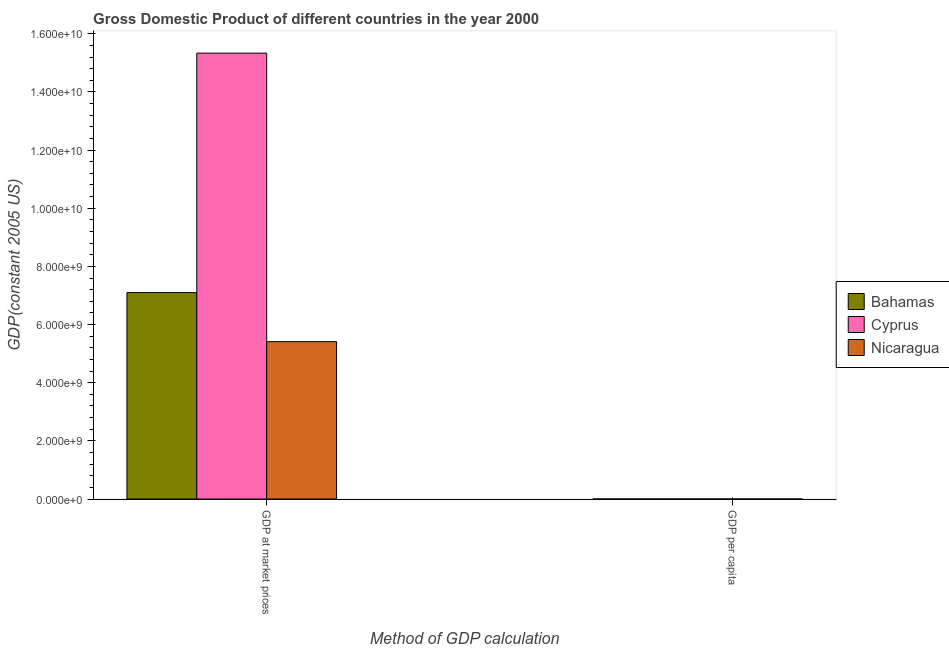How many different coloured bars are there?
Provide a succinct answer. 3. How many groups of bars are there?
Ensure brevity in your answer.  2. Are the number of bars on each tick of the X-axis equal?
Provide a short and direct response. Yes. How many bars are there on the 1st tick from the right?
Give a very brief answer. 3. What is the label of the 2nd group of bars from the left?
Provide a short and direct response. GDP per capita. What is the gdp at market prices in Bahamas?
Provide a short and direct response. 7.10e+09. Across all countries, what is the maximum gdp per capita?
Ensure brevity in your answer.  2.38e+04. Across all countries, what is the minimum gdp per capita?
Offer a terse response. 1076.67. In which country was the gdp per capita maximum?
Ensure brevity in your answer.  Bahamas. In which country was the gdp at market prices minimum?
Your answer should be compact. Nicaragua. What is the total gdp at market prices in the graph?
Provide a succinct answer. 2.78e+1. What is the difference between the gdp per capita in Nicaragua and that in Bahamas?
Provide a succinct answer. -2.28e+04. What is the difference between the gdp at market prices in Bahamas and the gdp per capita in Cyprus?
Your response must be concise. 7.10e+09. What is the average gdp per capita per country?
Ensure brevity in your answer.  1.57e+04. What is the difference between the gdp per capita and gdp at market prices in Nicaragua?
Make the answer very short. -5.41e+09. In how many countries, is the gdp at market prices greater than 10400000000 US$?
Keep it short and to the point. 1. What is the ratio of the gdp at market prices in Nicaragua to that in Cyprus?
Provide a succinct answer. 0.35. What does the 2nd bar from the left in GDP at market prices represents?
Your answer should be compact. Cyprus. What does the 3rd bar from the right in GDP per capita represents?
Give a very brief answer. Bahamas. How many bars are there?
Keep it short and to the point. 6. What is the difference between two consecutive major ticks on the Y-axis?
Ensure brevity in your answer.  2.00e+09. Does the graph contain any zero values?
Your answer should be very brief. No. Does the graph contain grids?
Ensure brevity in your answer.  No. How many legend labels are there?
Ensure brevity in your answer.  3. How are the legend labels stacked?
Offer a terse response. Vertical. What is the title of the graph?
Keep it short and to the point. Gross Domestic Product of different countries in the year 2000. Does "Fragile and conflict affected situations" appear as one of the legend labels in the graph?
Ensure brevity in your answer.  No. What is the label or title of the X-axis?
Offer a terse response. Method of GDP calculation. What is the label or title of the Y-axis?
Keep it short and to the point. GDP(constant 2005 US). What is the GDP(constant 2005 US) in Bahamas in GDP at market prices?
Provide a succinct answer. 7.10e+09. What is the GDP(constant 2005 US) in Cyprus in GDP at market prices?
Offer a terse response. 1.53e+1. What is the GDP(constant 2005 US) of Nicaragua in GDP at market prices?
Offer a very short reply. 5.41e+09. What is the GDP(constant 2005 US) of Bahamas in GDP per capita?
Your answer should be very brief. 2.38e+04. What is the GDP(constant 2005 US) in Cyprus in GDP per capita?
Your answer should be compact. 2.21e+04. What is the GDP(constant 2005 US) of Nicaragua in GDP per capita?
Your answer should be compact. 1076.67. Across all Method of GDP calculation, what is the maximum GDP(constant 2005 US) in Bahamas?
Your answer should be compact. 7.10e+09. Across all Method of GDP calculation, what is the maximum GDP(constant 2005 US) in Cyprus?
Offer a very short reply. 1.53e+1. Across all Method of GDP calculation, what is the maximum GDP(constant 2005 US) in Nicaragua?
Provide a succinct answer. 5.41e+09. Across all Method of GDP calculation, what is the minimum GDP(constant 2005 US) of Bahamas?
Your answer should be very brief. 2.38e+04. Across all Method of GDP calculation, what is the minimum GDP(constant 2005 US) in Cyprus?
Give a very brief answer. 2.21e+04. Across all Method of GDP calculation, what is the minimum GDP(constant 2005 US) of Nicaragua?
Your answer should be compact. 1076.67. What is the total GDP(constant 2005 US) of Bahamas in the graph?
Your answer should be compact. 7.10e+09. What is the total GDP(constant 2005 US) in Cyprus in the graph?
Make the answer very short. 1.53e+1. What is the total GDP(constant 2005 US) in Nicaragua in the graph?
Keep it short and to the point. 5.41e+09. What is the difference between the GDP(constant 2005 US) of Bahamas in GDP at market prices and that in GDP per capita?
Ensure brevity in your answer.  7.10e+09. What is the difference between the GDP(constant 2005 US) in Cyprus in GDP at market prices and that in GDP per capita?
Make the answer very short. 1.53e+1. What is the difference between the GDP(constant 2005 US) in Nicaragua in GDP at market prices and that in GDP per capita?
Your answer should be very brief. 5.41e+09. What is the difference between the GDP(constant 2005 US) in Bahamas in GDP at market prices and the GDP(constant 2005 US) in Cyprus in GDP per capita?
Provide a succinct answer. 7.10e+09. What is the difference between the GDP(constant 2005 US) of Bahamas in GDP at market prices and the GDP(constant 2005 US) of Nicaragua in GDP per capita?
Ensure brevity in your answer.  7.10e+09. What is the difference between the GDP(constant 2005 US) in Cyprus in GDP at market prices and the GDP(constant 2005 US) in Nicaragua in GDP per capita?
Your answer should be very brief. 1.53e+1. What is the average GDP(constant 2005 US) in Bahamas per Method of GDP calculation?
Your answer should be compact. 3.55e+09. What is the average GDP(constant 2005 US) in Cyprus per Method of GDP calculation?
Provide a short and direct response. 7.67e+09. What is the average GDP(constant 2005 US) of Nicaragua per Method of GDP calculation?
Your answer should be compact. 2.71e+09. What is the difference between the GDP(constant 2005 US) of Bahamas and GDP(constant 2005 US) of Cyprus in GDP at market prices?
Your response must be concise. -8.24e+09. What is the difference between the GDP(constant 2005 US) in Bahamas and GDP(constant 2005 US) in Nicaragua in GDP at market prices?
Offer a very short reply. 1.69e+09. What is the difference between the GDP(constant 2005 US) of Cyprus and GDP(constant 2005 US) of Nicaragua in GDP at market prices?
Offer a very short reply. 9.92e+09. What is the difference between the GDP(constant 2005 US) in Bahamas and GDP(constant 2005 US) in Cyprus in GDP per capita?
Your response must be concise. 1734.99. What is the difference between the GDP(constant 2005 US) in Bahamas and GDP(constant 2005 US) in Nicaragua in GDP per capita?
Provide a succinct answer. 2.28e+04. What is the difference between the GDP(constant 2005 US) of Cyprus and GDP(constant 2005 US) of Nicaragua in GDP per capita?
Offer a terse response. 2.10e+04. What is the ratio of the GDP(constant 2005 US) in Bahamas in GDP at market prices to that in GDP per capita?
Your answer should be very brief. 2.98e+05. What is the ratio of the GDP(constant 2005 US) in Cyprus in GDP at market prices to that in GDP per capita?
Ensure brevity in your answer.  6.94e+05. What is the ratio of the GDP(constant 2005 US) of Nicaragua in GDP at market prices to that in GDP per capita?
Give a very brief answer. 5.03e+06. What is the difference between the highest and the second highest GDP(constant 2005 US) in Bahamas?
Offer a terse response. 7.10e+09. What is the difference between the highest and the second highest GDP(constant 2005 US) in Cyprus?
Your answer should be very brief. 1.53e+1. What is the difference between the highest and the second highest GDP(constant 2005 US) in Nicaragua?
Your answer should be compact. 5.41e+09. What is the difference between the highest and the lowest GDP(constant 2005 US) in Bahamas?
Provide a short and direct response. 7.10e+09. What is the difference between the highest and the lowest GDP(constant 2005 US) in Cyprus?
Offer a terse response. 1.53e+1. What is the difference between the highest and the lowest GDP(constant 2005 US) of Nicaragua?
Provide a short and direct response. 5.41e+09. 